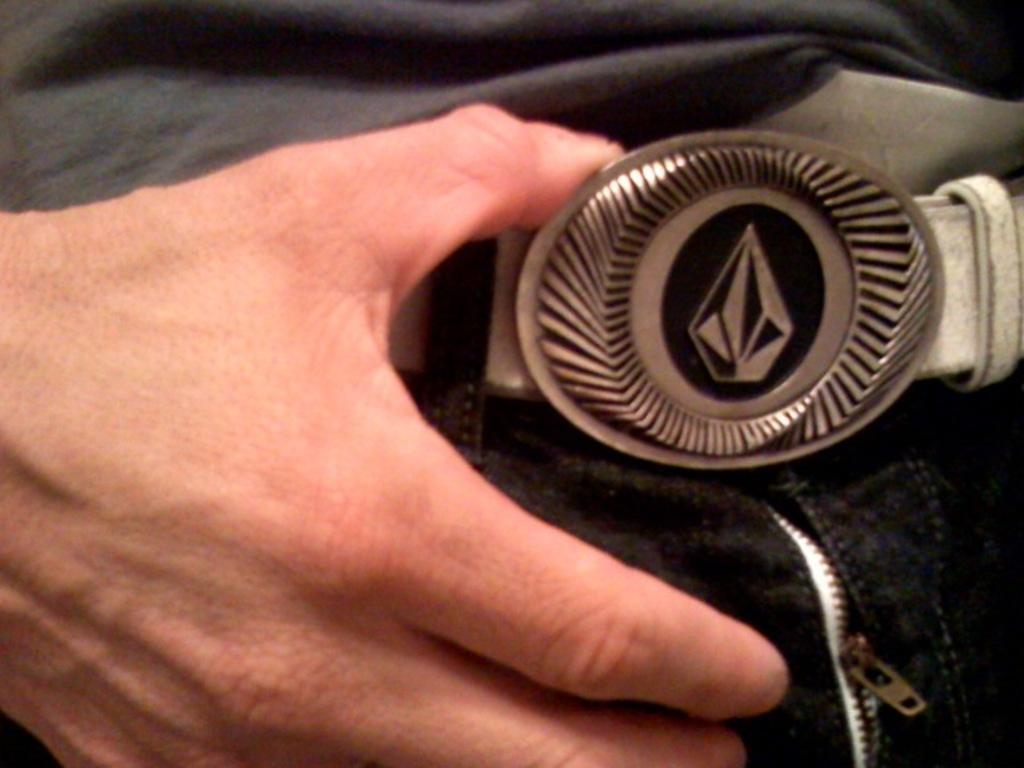How would you summarize this image in a sentence or two? In this picture we can see a person hand and the person is holding a belt. 